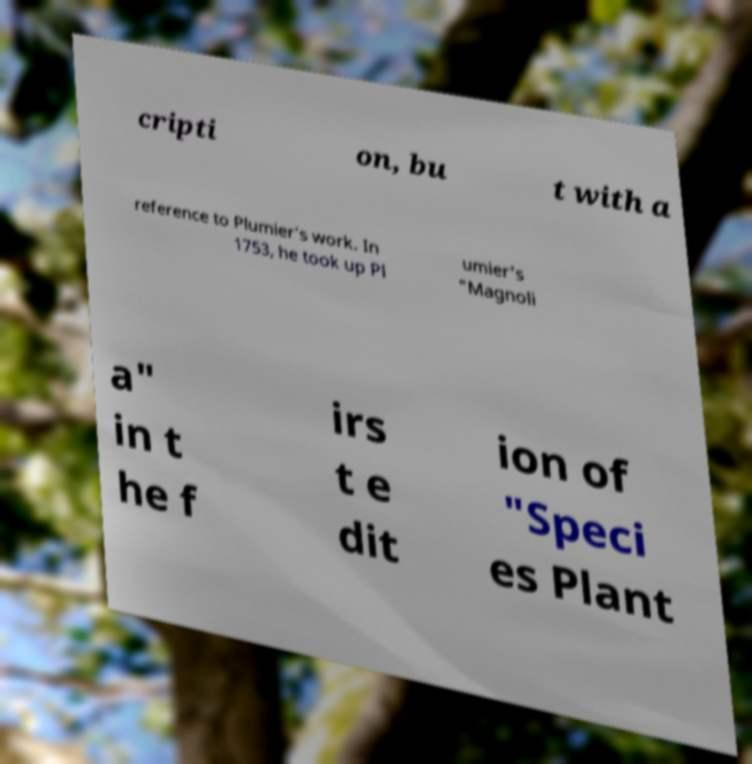I need the written content from this picture converted into text. Can you do that? cripti on, bu t with a reference to Plumier's work. In 1753, he took up Pl umier's "Magnoli a" in t he f irs t e dit ion of "Speci es Plant 